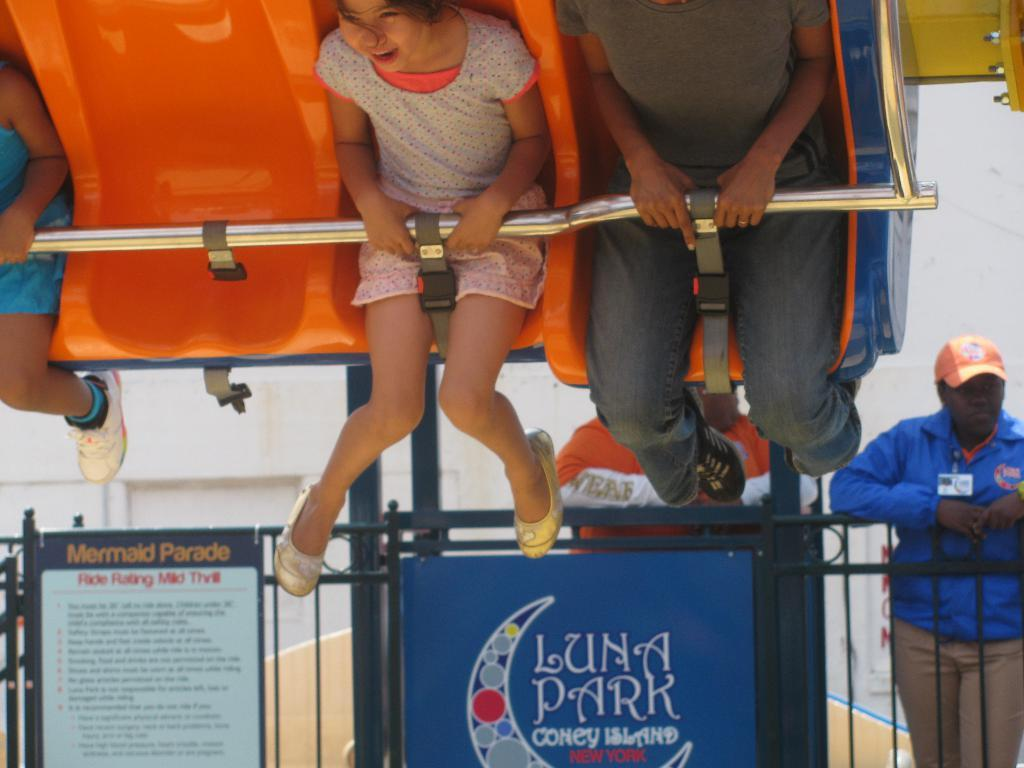What is present on the boundary in the image? There are posters on a boundary in the image. Where are the people located in the image? People are standing behind the boundary at the bottom side of the image, and some are sitting at the top side of the image, possibly on a swing. Can you see any donkeys swimming in the ocean in the image? There is no ocean or donkey present in the image. What type of insect is sitting on the swing with the people at the top side of the image? There are no insects present in the image; only people are visible on the swing. 